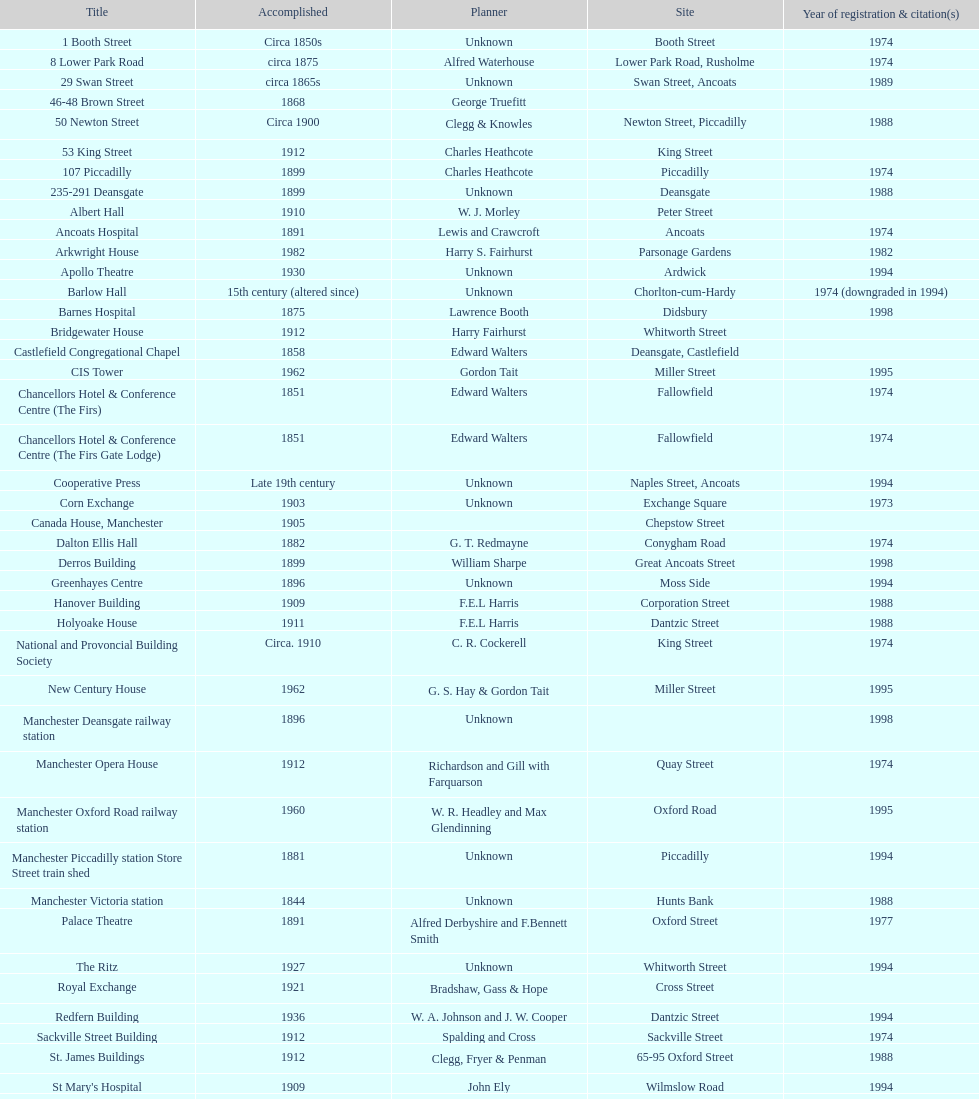Was charles heathcote the architect of ancoats hospital and apollo theatre? No. Would you be able to parse every entry in this table? {'header': ['Title', 'Accomplished', 'Planner', 'Site', 'Year of registration & citation(s)'], 'rows': [['1 Booth Street', 'Circa 1850s', 'Unknown', 'Booth Street', '1974'], ['8 Lower Park Road', 'circa 1875', 'Alfred Waterhouse', 'Lower Park Road, Rusholme', '1974'], ['29 Swan Street', 'circa 1865s', 'Unknown', 'Swan Street, Ancoats', '1989'], ['46-48 Brown Street', '1868', 'George Truefitt', '', ''], ['50 Newton Street', 'Circa 1900', 'Clegg & Knowles', 'Newton Street, Piccadilly', '1988'], ['53 King Street', '1912', 'Charles Heathcote', 'King Street', ''], ['107 Piccadilly', '1899', 'Charles Heathcote', 'Piccadilly', '1974'], ['235-291 Deansgate', '1899', 'Unknown', 'Deansgate', '1988'], ['Albert Hall', '1910', 'W. J. Morley', 'Peter Street', ''], ['Ancoats Hospital', '1891', 'Lewis and Crawcroft', 'Ancoats', '1974'], ['Arkwright House', '1982', 'Harry S. Fairhurst', 'Parsonage Gardens', '1982'], ['Apollo Theatre', '1930', 'Unknown', 'Ardwick', '1994'], ['Barlow Hall', '15th century (altered since)', 'Unknown', 'Chorlton-cum-Hardy', '1974 (downgraded in 1994)'], ['Barnes Hospital', '1875', 'Lawrence Booth', 'Didsbury', '1998'], ['Bridgewater House', '1912', 'Harry Fairhurst', 'Whitworth Street', ''], ['Castlefield Congregational Chapel', '1858', 'Edward Walters', 'Deansgate, Castlefield', ''], ['CIS Tower', '1962', 'Gordon Tait', 'Miller Street', '1995'], ['Chancellors Hotel & Conference Centre (The Firs)', '1851', 'Edward Walters', 'Fallowfield', '1974'], ['Chancellors Hotel & Conference Centre (The Firs Gate Lodge)', '1851', 'Edward Walters', 'Fallowfield', '1974'], ['Cooperative Press', 'Late 19th century', 'Unknown', 'Naples Street, Ancoats', '1994'], ['Corn Exchange', '1903', 'Unknown', 'Exchange Square', '1973'], ['Canada House, Manchester', '1905', '', 'Chepstow Street', ''], ['Dalton Ellis Hall', '1882', 'G. T. Redmayne', 'Conygham Road', '1974'], ['Derros Building', '1899', 'William Sharpe', 'Great Ancoats Street', '1998'], ['Greenhayes Centre', '1896', 'Unknown', 'Moss Side', '1994'], ['Hanover Building', '1909', 'F.E.L Harris', 'Corporation Street', '1988'], ['Holyoake House', '1911', 'F.E.L Harris', 'Dantzic Street', '1988'], ['National and Provoncial Building Society', 'Circa. 1910', 'C. R. Cockerell', 'King Street', '1974'], ['New Century House', '1962', 'G. S. Hay & Gordon Tait', 'Miller Street', '1995'], ['Manchester Deansgate railway station', '1896', 'Unknown', '', '1998'], ['Manchester Opera House', '1912', 'Richardson and Gill with Farquarson', 'Quay Street', '1974'], ['Manchester Oxford Road railway station', '1960', 'W. R. Headley and Max Glendinning', 'Oxford Road', '1995'], ['Manchester Piccadilly station Store Street train shed', '1881', 'Unknown', 'Piccadilly', '1994'], ['Manchester Victoria station', '1844', 'Unknown', 'Hunts Bank', '1988'], ['Palace Theatre', '1891', 'Alfred Derbyshire and F.Bennett Smith', 'Oxford Street', '1977'], ['The Ritz', '1927', 'Unknown', 'Whitworth Street', '1994'], ['Royal Exchange', '1921', 'Bradshaw, Gass & Hope', 'Cross Street', ''], ['Redfern Building', '1936', 'W. A. Johnson and J. W. Cooper', 'Dantzic Street', '1994'], ['Sackville Street Building', '1912', 'Spalding and Cross', 'Sackville Street', '1974'], ['St. James Buildings', '1912', 'Clegg, Fryer & Penman', '65-95 Oxford Street', '1988'], ["St Mary's Hospital", '1909', 'John Ely', 'Wilmslow Road', '1994'], ['Samuel Alexander Building', '1919', 'Percy Scott Worthington', 'Oxford Road', '2010'], ['Ship Canal House', '1927', 'Harry S. Fairhurst', 'King Street', '1982'], ['Smithfield Market Hall', '1857', 'Unknown', 'Swan Street, Ancoats', '1973'], ['Strangeways Gaol Gatehouse', '1868', 'Alfred Waterhouse', 'Sherborne Street', '1974'], ['Strangeways Prison ventilation and watch tower', '1868', 'Alfred Waterhouse', 'Sherborne Street', '1974'], ['Theatre Royal', '1845', 'Irwin and Chester', 'Peter Street', '1974'], ['Toast Rack', '1960', 'L. C. Howitt', 'Fallowfield', '1999'], ['The Old Wellington Inn', 'Mid-16th century', 'Unknown', 'Shambles Square', '1952'], ['Whitworth Park Mansions', 'Circa 1840s', 'Unknown', 'Whitworth Park', '1974']]} 